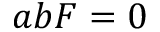Convert formula to latex. <formula><loc_0><loc_0><loc_500><loc_500>a b F = 0</formula> 